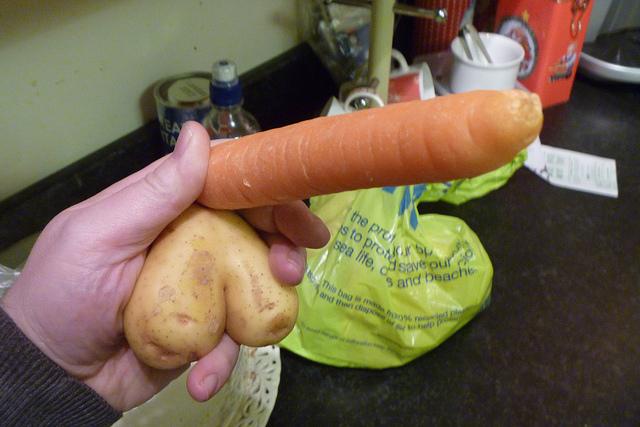What is the orange vegetable?
Be succinct. Carrot. How many carrots are in the picture?
Be succinct. 1. Does this table need cleaning up?
Short answer required. No. What shape are the vegetables making?
Give a very brief answer. Penis. 